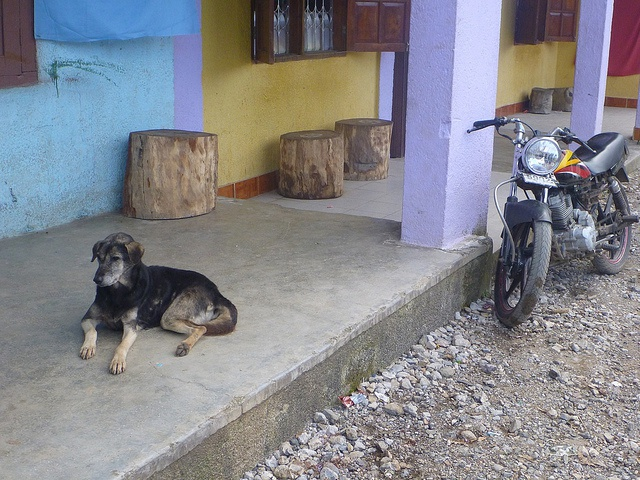Describe the objects in this image and their specific colors. I can see motorcycle in black, gray, and darkgray tones and dog in black, gray, and darkgray tones in this image. 